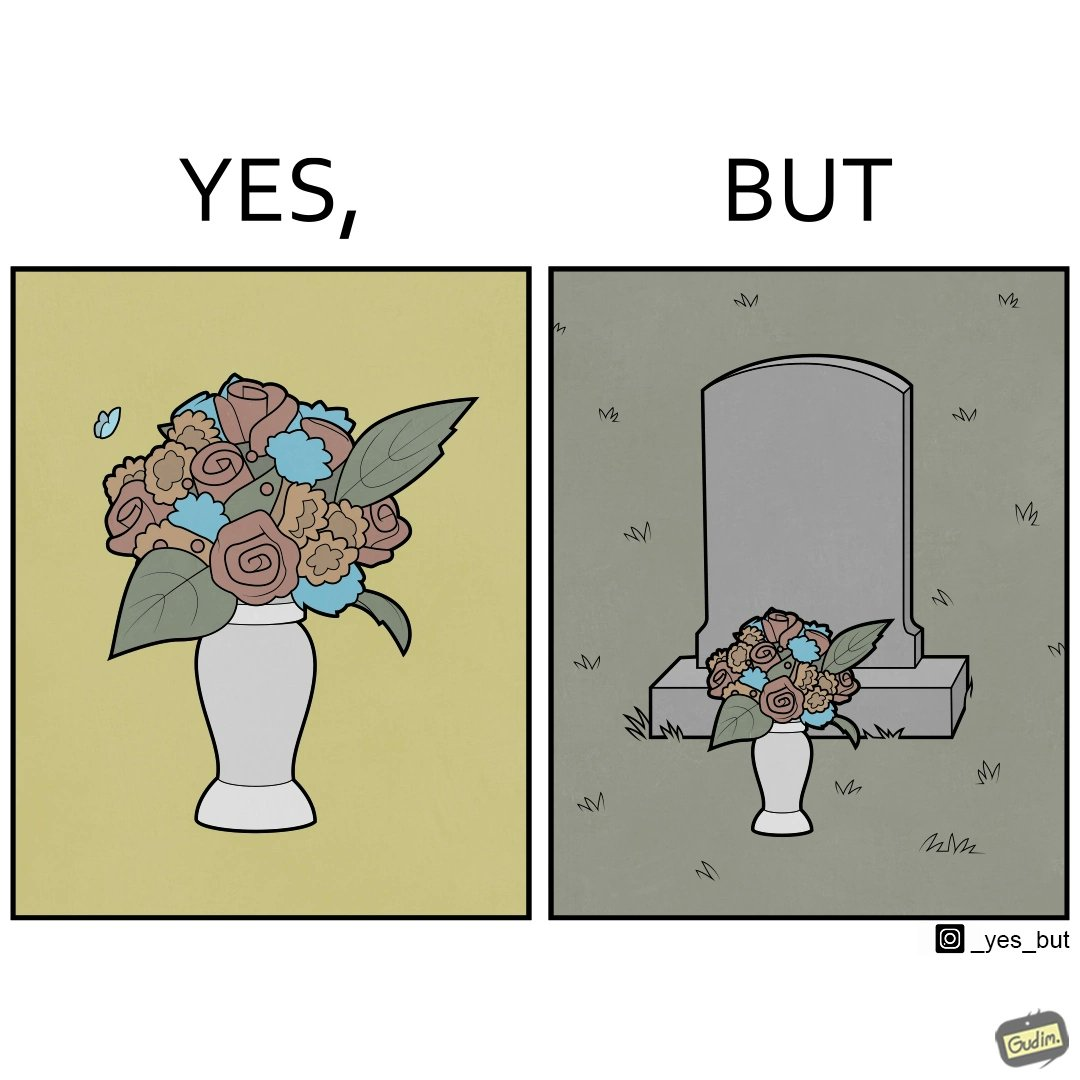Provide a description of this image. The image is ironic, because in the first image a vase full of different beautiful flowers is seen which spreads a feeling of positivity, cheerfulness etc., whereas in the second image when the same vase is put in front of a grave stone it produces a feeling of sorrow 